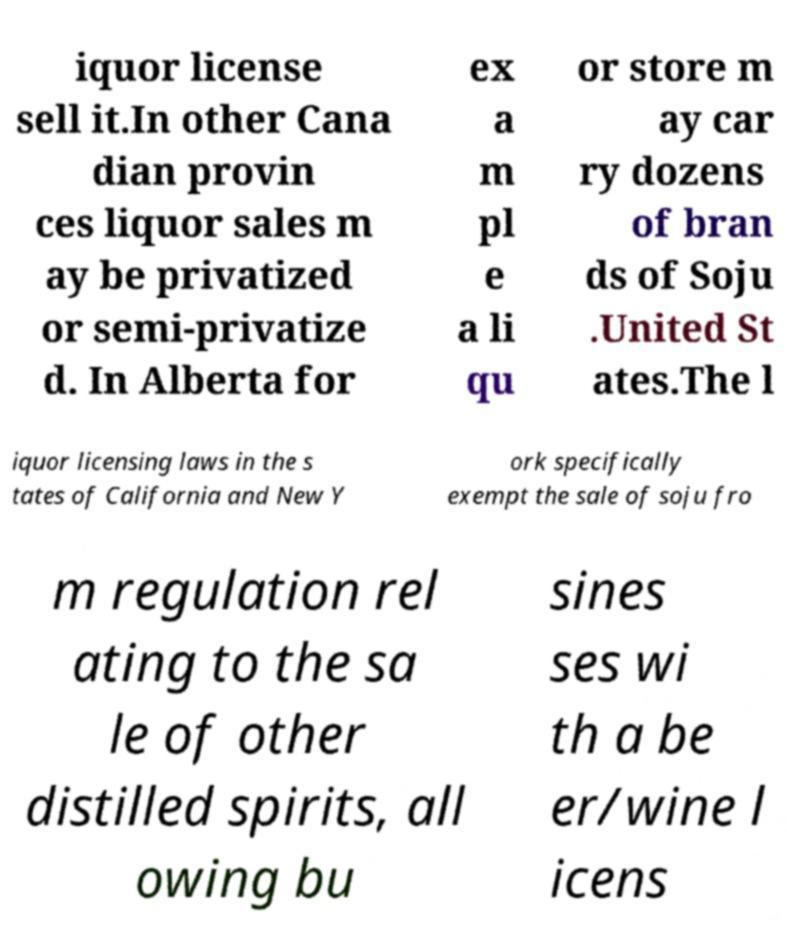There's text embedded in this image that I need extracted. Can you transcribe it verbatim? iquor license sell it.In other Cana dian provin ces liquor sales m ay be privatized or semi-privatize d. In Alberta for ex a m pl e a li qu or store m ay car ry dozens of bran ds of Soju .United St ates.The l iquor licensing laws in the s tates of California and New Y ork specifically exempt the sale of soju fro m regulation rel ating to the sa le of other distilled spirits, all owing bu sines ses wi th a be er/wine l icens 